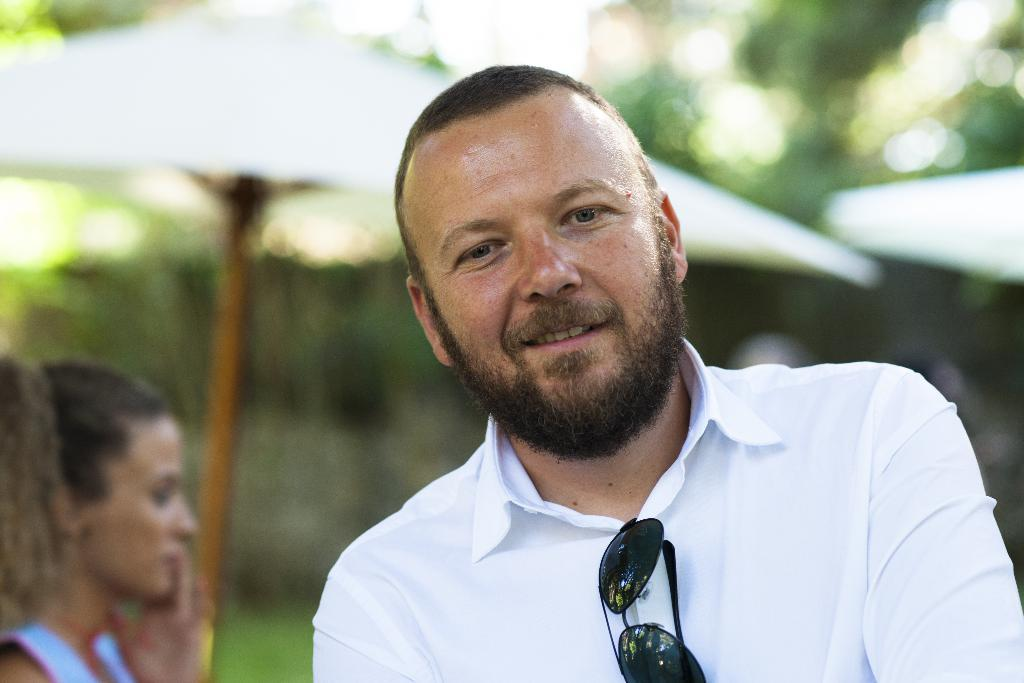What is the person in the foreground of the image wearing? The person in the foreground of the image is wearing a white shirt. Can you describe the person in the background of the image? There is a woman in the background of the image. What object is present in the image that can provide shade? There is an umbrella in the image. What type of vegetation can be seen in the image? There are trees in the image. What type of jeans is the person wearing in the image? The provided facts do not mention jeans; the person is wearing a white shirt. Can you describe the comb that the woman in the background is using in the image? There is no comb present in the image. 